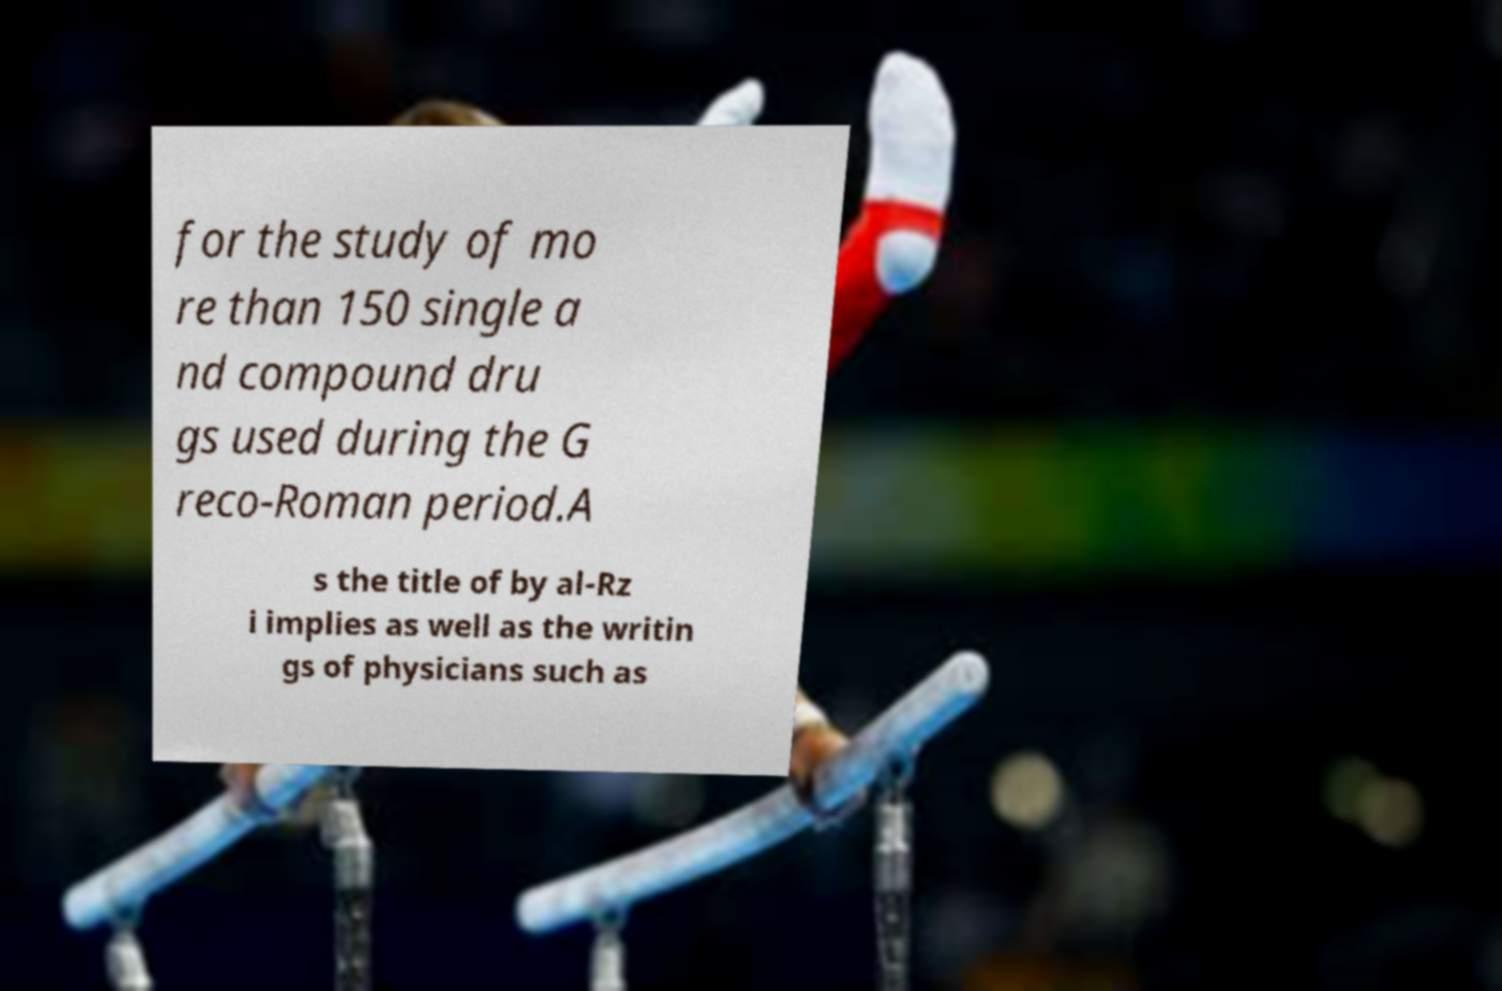Could you assist in decoding the text presented in this image and type it out clearly? for the study of mo re than 150 single a nd compound dru gs used during the G reco-Roman period.A s the title of by al-Rz i implies as well as the writin gs of physicians such as 